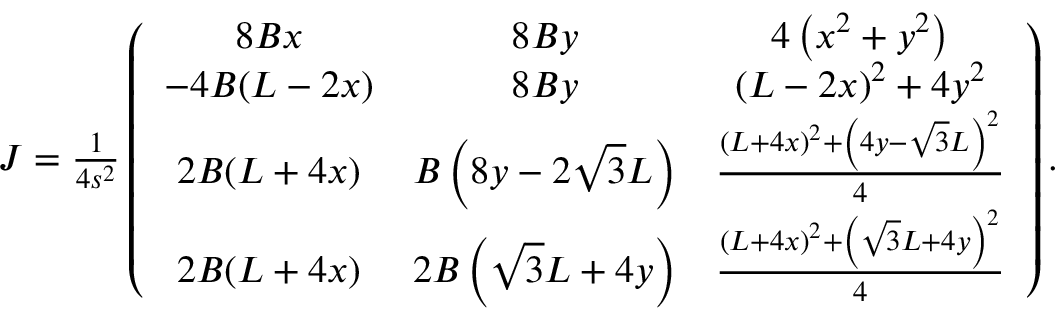<formula> <loc_0><loc_0><loc_500><loc_500>\begin{array} { r } { J = \frac { 1 } 4 s ^ { 2 } } \left ( \begin{array} { c c c } { 8 B x } & { 8 B y } & { 4 \left ( x ^ { 2 } + y ^ { 2 } \right ) } \\ { - 4 B ( L - 2 x ) } & { 8 B y } & { ( L - 2 x ) ^ { 2 } + 4 y ^ { 2 } } \\ { 2 B ( L + 4 x ) } & { B \left ( 8 y - 2 \sqrt { 3 } L \right ) } & { \frac { \left ( L + 4 x \right ) ^ { 2 } + \left ( 4 y - \sqrt { 3 } L \right ) ^ { 2 } } { 4 } } \\ { 2 B ( L + 4 x ) } & { 2 B \left ( \sqrt { 3 } L + 4 y \right ) } & { \frac { \left ( L + 4 x \right ) ^ { 2 } + \left ( \sqrt { 3 } L + 4 y \right ) ^ { 2 } } { 4 } } \end{array} \right ) . } \end{array}</formula> 